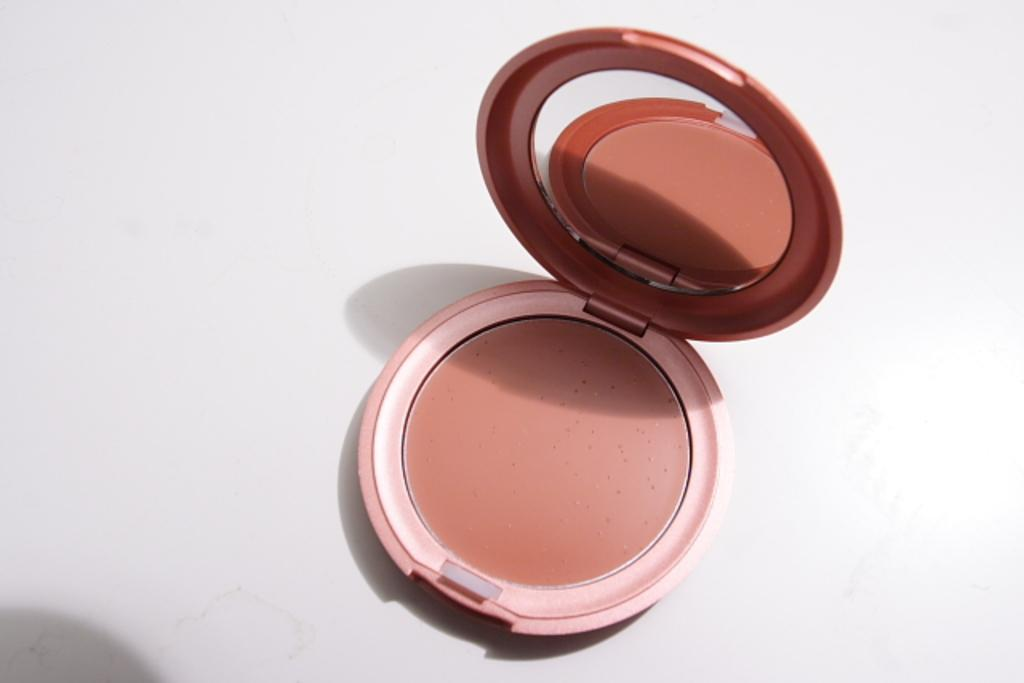What is the main object in the image? There is a compact powder in the image. Where is the compact powder located? The compact powder is placed on a table. What type of oil is being used to open the umbrella in the image? There is no oil or umbrella present in the image; it only features a compact powder placed on a table. 